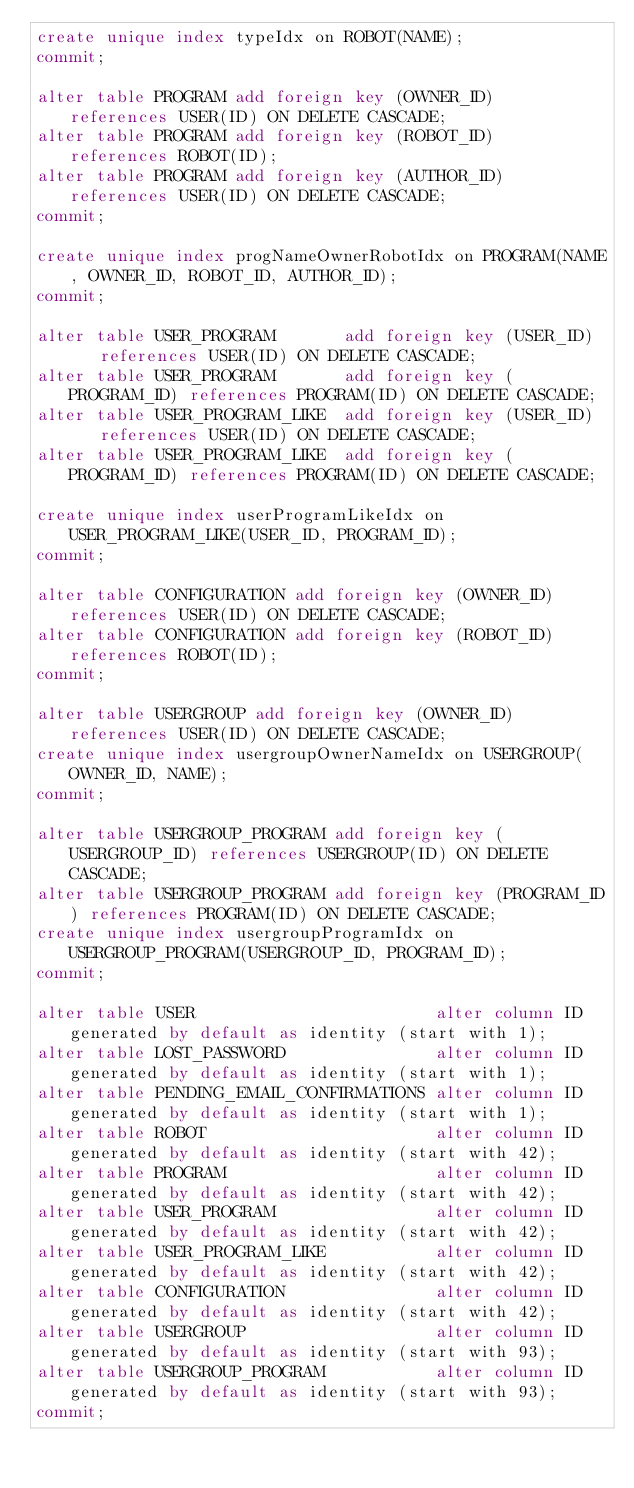<code> <loc_0><loc_0><loc_500><loc_500><_SQL_>create unique index typeIdx on ROBOT(NAME);
commit;

alter table PROGRAM add foreign key (OWNER_ID)  references USER(ID) ON DELETE CASCADE;
alter table PROGRAM add foreign key (ROBOT_ID)  references ROBOT(ID);
alter table PROGRAM add foreign key (AUTHOR_ID) references USER(ID) ON DELETE CASCADE;
commit;

create unique index progNameOwnerRobotIdx on PROGRAM(NAME, OWNER_ID, ROBOT_ID, AUTHOR_ID);
commit;

alter table USER_PROGRAM       add foreign key (USER_ID)    references USER(ID) ON DELETE CASCADE;
alter table USER_PROGRAM       add foreign key (PROGRAM_ID) references PROGRAM(ID) ON DELETE CASCADE;
alter table USER_PROGRAM_LIKE  add foreign key (USER_ID)    references USER(ID) ON DELETE CASCADE;
alter table USER_PROGRAM_LIKE  add foreign key (PROGRAM_ID) references PROGRAM(ID) ON DELETE CASCADE;

create unique index userProgramLikeIdx on USER_PROGRAM_LIKE(USER_ID, PROGRAM_ID);
commit;

alter table CONFIGURATION add foreign key (OWNER_ID) references USER(ID) ON DELETE CASCADE;
alter table CONFIGURATION add foreign key (ROBOT_ID) references ROBOT(ID);
commit;

alter table USERGROUP add foreign key (OWNER_ID) references USER(ID) ON DELETE CASCADE;
create unique index usergroupOwnerNameIdx on USERGROUP(OWNER_ID, NAME);
commit;

alter table USERGROUP_PROGRAM add foreign key (USERGROUP_ID) references USERGROUP(ID) ON DELETE CASCADE;
alter table USERGROUP_PROGRAM add foreign key (PROGRAM_ID) references PROGRAM(ID) ON DELETE CASCADE;
create unique index usergroupProgramIdx on USERGROUP_PROGRAM(USERGROUP_ID, PROGRAM_ID);
commit;

alter table USER                        alter column ID generated by default as identity (start with 1);
alter table LOST_PASSWORD               alter column ID generated by default as identity (start with 1);
alter table PENDING_EMAIL_CONFIRMATIONS alter column ID generated by default as identity (start with 1);
alter table ROBOT                       alter column ID generated by default as identity (start with 42);
alter table PROGRAM                     alter column ID generated by default as identity (start with 42);
alter table USER_PROGRAM                alter column ID generated by default as identity (start with 42);
alter table USER_PROGRAM_LIKE           alter column ID generated by default as identity (start with 42);
alter table CONFIGURATION               alter column ID generated by default as identity (start with 42);
alter table USERGROUP                   alter column ID generated by default as identity (start with 93);
alter table USERGROUP_PROGRAM           alter column ID generated by default as identity (start with 93);
commit;
</code> 